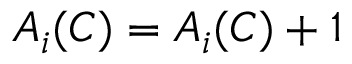Convert formula to latex. <formula><loc_0><loc_0><loc_500><loc_500>A _ { i } ( C ) = A _ { i } ( C ) + 1</formula> 